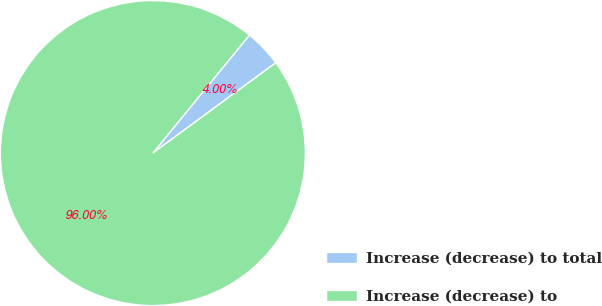Convert chart. <chart><loc_0><loc_0><loc_500><loc_500><pie_chart><fcel>Increase (decrease) to total<fcel>Increase (decrease) to<nl><fcel>4.0%<fcel>96.0%<nl></chart> 